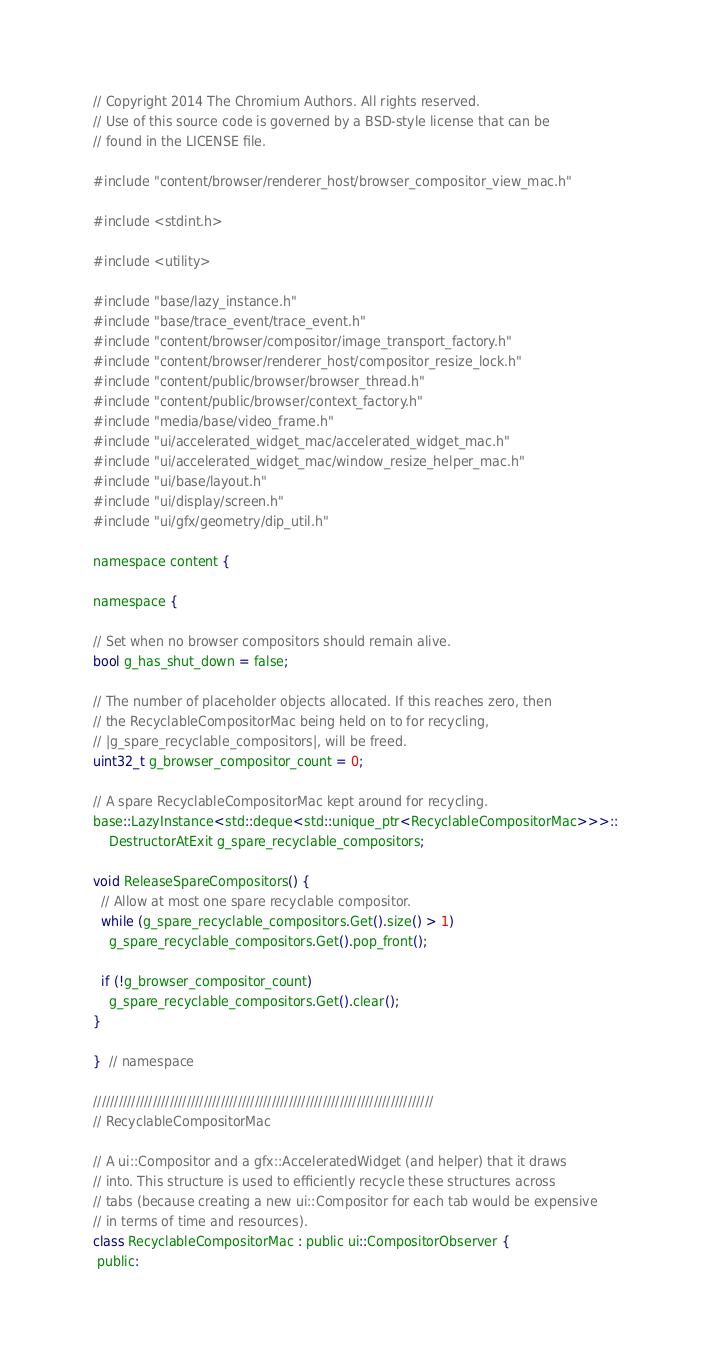Convert code to text. <code><loc_0><loc_0><loc_500><loc_500><_ObjectiveC_>// Copyright 2014 The Chromium Authors. All rights reserved.
// Use of this source code is governed by a BSD-style license that can be
// found in the LICENSE file.

#include "content/browser/renderer_host/browser_compositor_view_mac.h"

#include <stdint.h>

#include <utility>

#include "base/lazy_instance.h"
#include "base/trace_event/trace_event.h"
#include "content/browser/compositor/image_transport_factory.h"
#include "content/browser/renderer_host/compositor_resize_lock.h"
#include "content/public/browser/browser_thread.h"
#include "content/public/browser/context_factory.h"
#include "media/base/video_frame.h"
#include "ui/accelerated_widget_mac/accelerated_widget_mac.h"
#include "ui/accelerated_widget_mac/window_resize_helper_mac.h"
#include "ui/base/layout.h"
#include "ui/display/screen.h"
#include "ui/gfx/geometry/dip_util.h"

namespace content {

namespace {

// Set when no browser compositors should remain alive.
bool g_has_shut_down = false;

// The number of placeholder objects allocated. If this reaches zero, then
// the RecyclableCompositorMac being held on to for recycling,
// |g_spare_recyclable_compositors|, will be freed.
uint32_t g_browser_compositor_count = 0;

// A spare RecyclableCompositorMac kept around for recycling.
base::LazyInstance<std::deque<std::unique_ptr<RecyclableCompositorMac>>>::
    DestructorAtExit g_spare_recyclable_compositors;

void ReleaseSpareCompositors() {
  // Allow at most one spare recyclable compositor.
  while (g_spare_recyclable_compositors.Get().size() > 1)
    g_spare_recyclable_compositors.Get().pop_front();

  if (!g_browser_compositor_count)
    g_spare_recyclable_compositors.Get().clear();
}

}  // namespace

////////////////////////////////////////////////////////////////////////////////
// RecyclableCompositorMac

// A ui::Compositor and a gfx::AcceleratedWidget (and helper) that it draws
// into. This structure is used to efficiently recycle these structures across
// tabs (because creating a new ui::Compositor for each tab would be expensive
// in terms of time and resources).
class RecyclableCompositorMac : public ui::CompositorObserver {
 public:</code> 